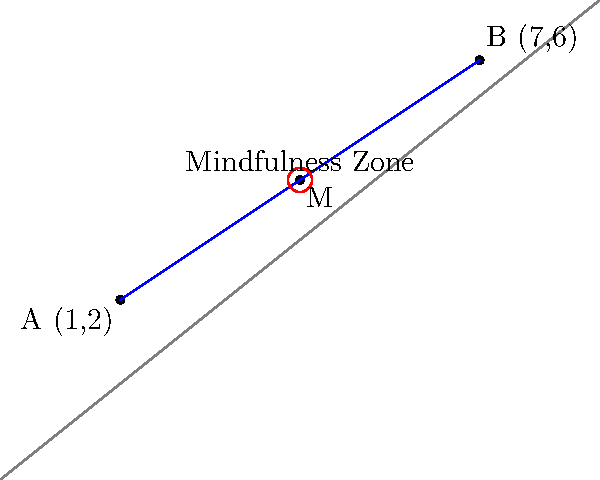During a mindfulness exercise, two athletes are positioned at coordinates A(1,2) and B(7,6) on a training field. The coach wants to place a marker at the midpoint of the line segment connecting these two athletes to designate the "Mindfulness Zone." What are the coordinates of this midpoint M? To find the midpoint M of the line segment connecting points A(1,2) and B(7,6), we use the midpoint formula:

$$ M = (\frac{x_1 + x_2}{2}, \frac{y_1 + y_2}{2}) $$

Where $(x_1, y_1)$ are the coordinates of point A, and $(x_2, y_2)$ are the coordinates of point B.

Step 1: Calculate the x-coordinate of the midpoint:
$$ x_M = \frac{x_1 + x_2}{2} = \frac{1 + 7}{2} = \frac{8}{2} = 4 $$

Step 2: Calculate the y-coordinate of the midpoint:
$$ y_M = \frac{y_1 + y_2}{2} = \frac{2 + 6}{2} = \frac{8}{2} = 4 $$

Therefore, the coordinates of the midpoint M are (4,4).
Answer: (4,4) 